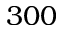Convert formula to latex. <formula><loc_0><loc_0><loc_500><loc_500>3 0 0</formula> 